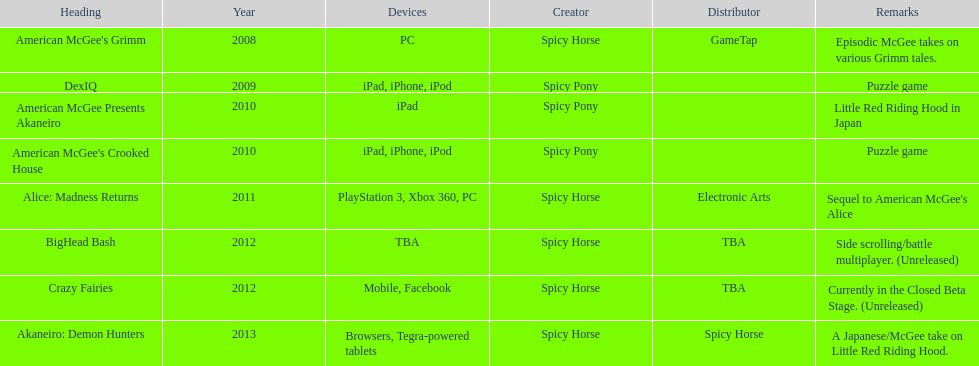What was the sole game released by electronic arts? Alice: Madness Returns. 